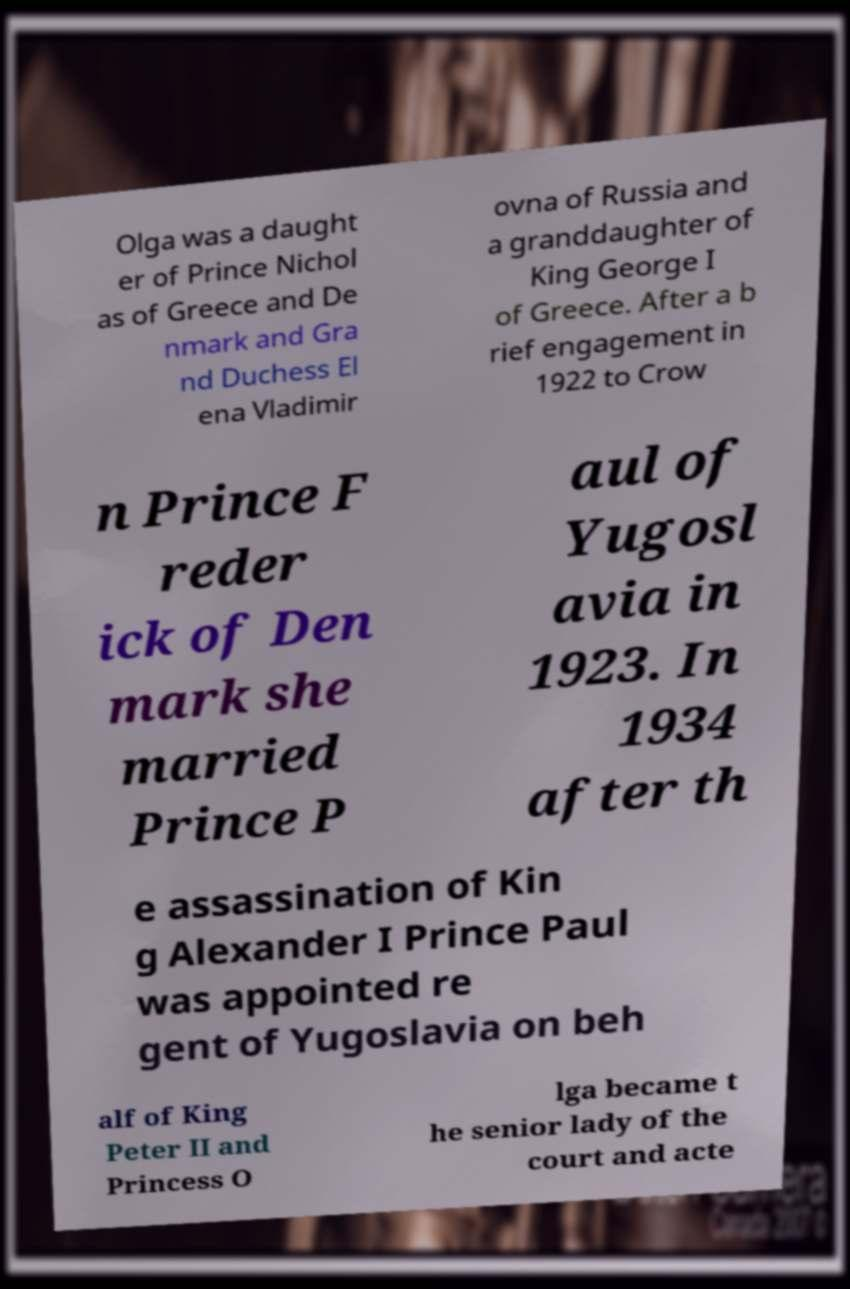Please identify and transcribe the text found in this image. Olga was a daught er of Prince Nichol as of Greece and De nmark and Gra nd Duchess El ena Vladimir ovna of Russia and a granddaughter of King George I of Greece. After a b rief engagement in 1922 to Crow n Prince F reder ick of Den mark she married Prince P aul of Yugosl avia in 1923. In 1934 after th e assassination of Kin g Alexander I Prince Paul was appointed re gent of Yugoslavia on beh alf of King Peter II and Princess O lga became t he senior lady of the court and acte 